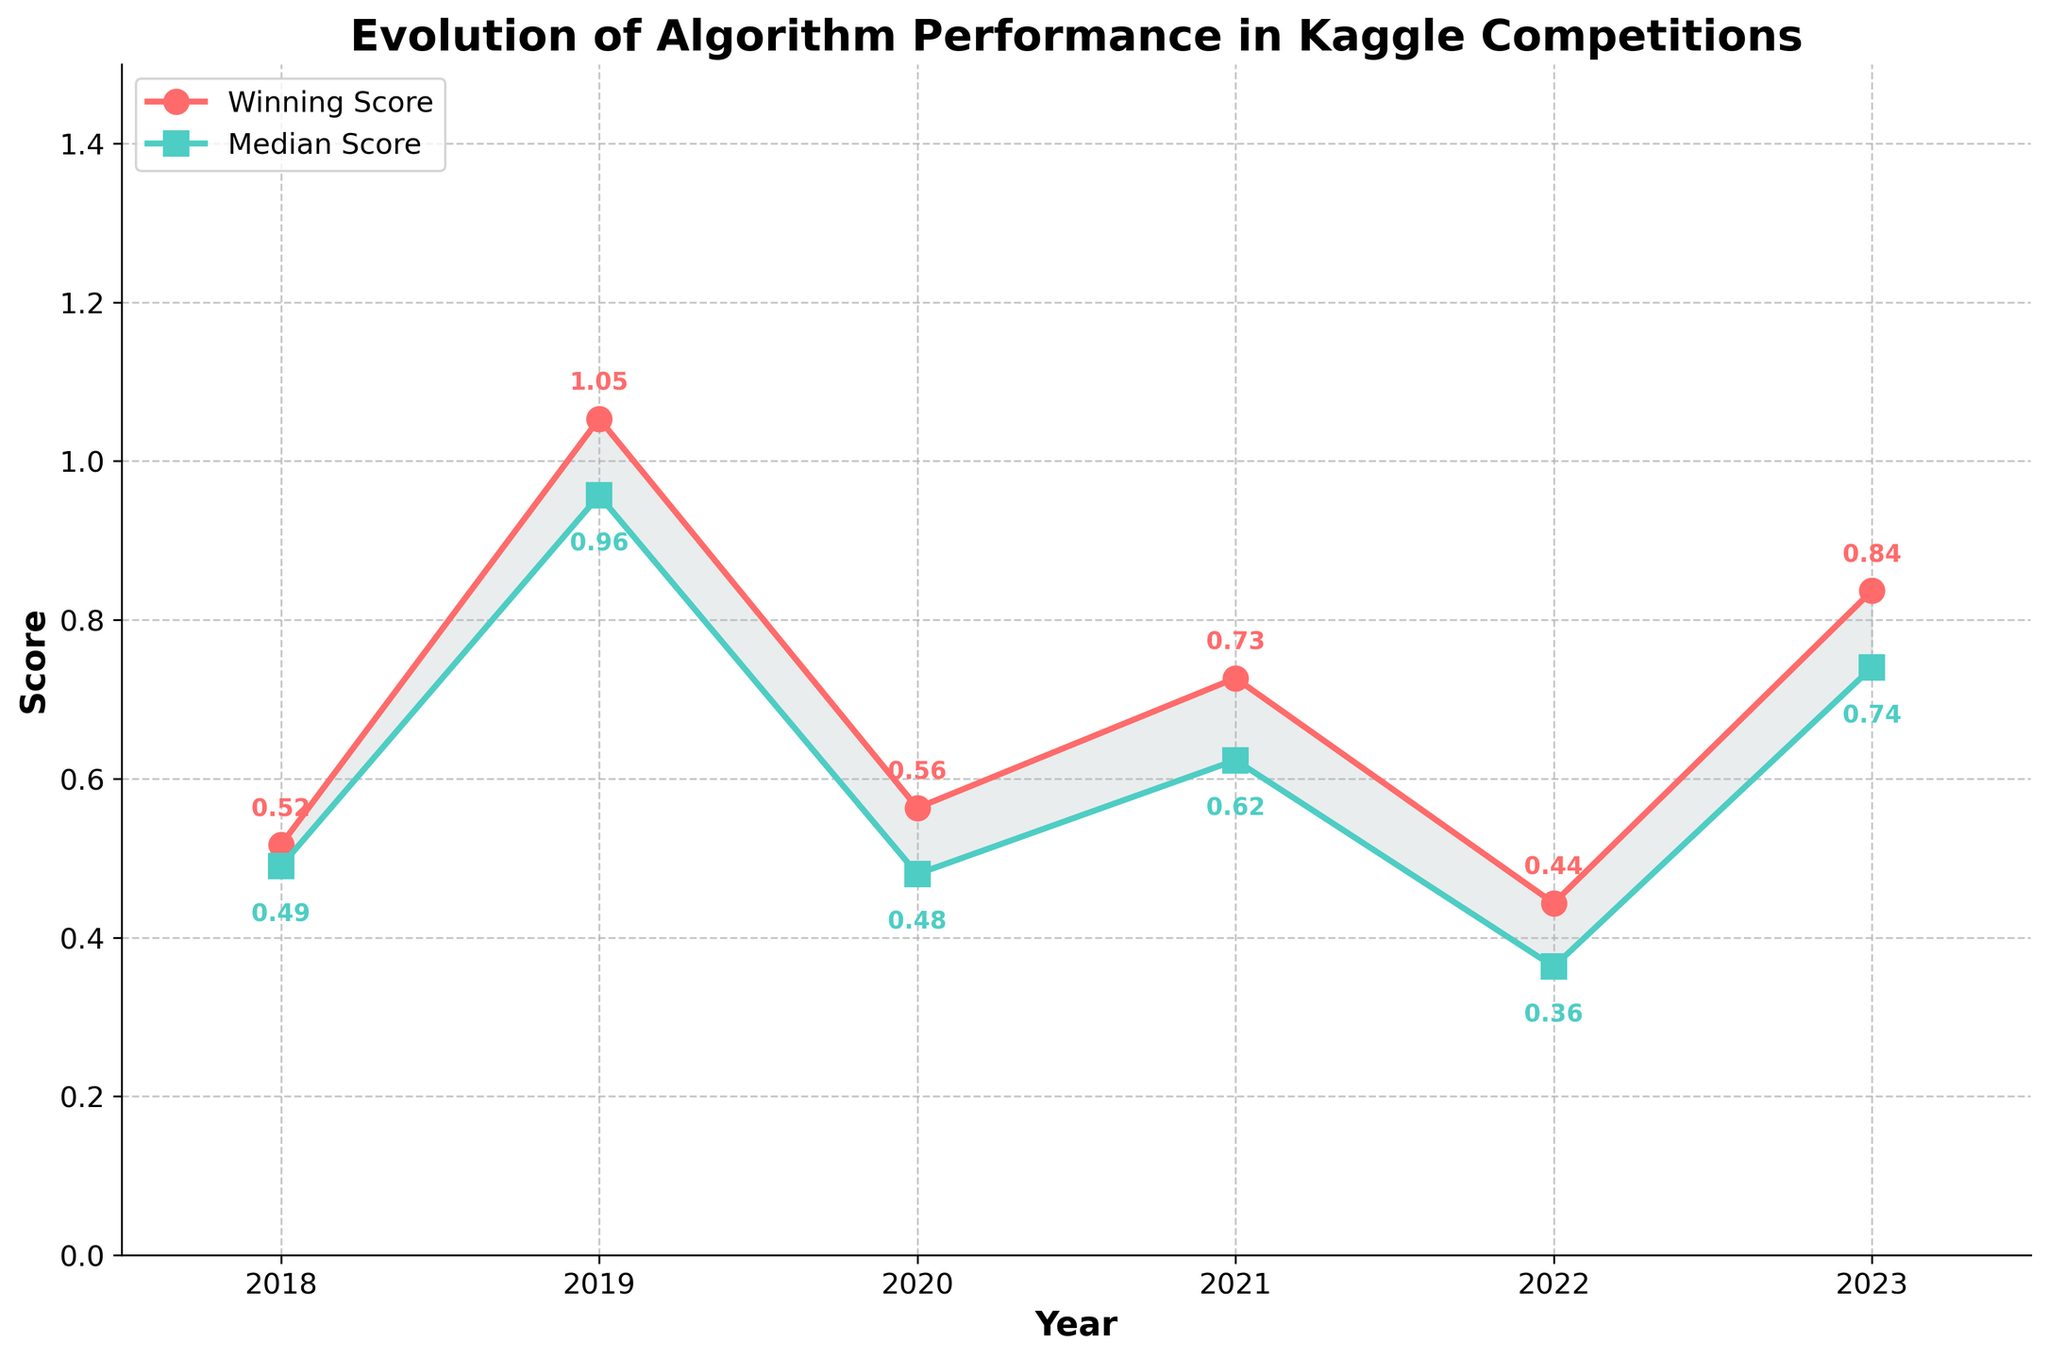What is the title of the plot? The title of the plot is visible at the top of the figure, and it reads "Evolution of Algorithm Performance in Kaggle Competitions."
Answer: Evolution of Algorithm Performance in Kaggle Competitions What colors are used for the Winning Score and Median Score lines? The Winning Score line is red, while the Median Score line is teal. This can be observed directly from the plot.
Answer: Red and Teal In which year does the winning score show the highest mean value? The line for the Winning Score reaches its peak in the year 2019. This can be seen as the highest point along the red line.
Answer: 2019 How has the mean Winning Score changed from 2018 to 2023? The Winning Score increases initially from 2018 to 2019, decreases till 2020, slowly rises again by 2021, and remains relatively stable by 2023. This can be inferred from the red line trend over the years.
Answer: Increased then decreased, then stayed relatively stable Which year shows the smallest difference between the mean Winning Score and the mean Median Score? To determine this, we can look at the vertical distance between the red and teal lines for each year. The smallest gap appears in 2022.
Answer: 2022 On average, do winning scores or median scores have a greater range of values over the years? To determine this, one must observe which line fluctuates more significantly. The red line showing Winning Scores has more extreme deviation while the teal stays more constrained.
Answer: Winning Scores What is the mean Median Score for the year 2021? The plot shows that the Median Score for 2021 is annotated as approximately 0.62 on the teal line.
Answer: 0.62 How does the mean Winning Score in 2021 compare to that in 2020? In the plot, the Winning Score for 2021 is higher than that for 2020, as the red line is positioned higher in 2021 compared to 2020.
Answer: Higher in 2021 Is there any year shown in which the mean Winning Score is lower than the mean Median Score? By inspecting both the red and teal lines over years, no occurrence of the red line being below the teal line can be observed.
Answer: No What trend is observed for the mean Median Score from 2018 to 2023? The mean Median Score, shown by the teal line, appears to have a slight decrease from 2018 to 2020, then increases until 2021 and stays stable by 2023. This can be inferred from the trend line.
Answer: Slight decrease and then stable 